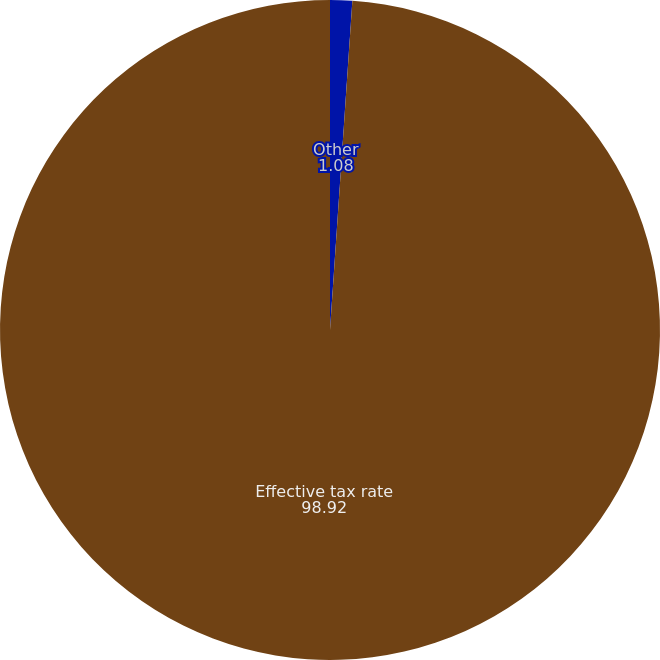Convert chart. <chart><loc_0><loc_0><loc_500><loc_500><pie_chart><fcel>Other<fcel>Effective tax rate<nl><fcel>1.08%<fcel>98.92%<nl></chart> 